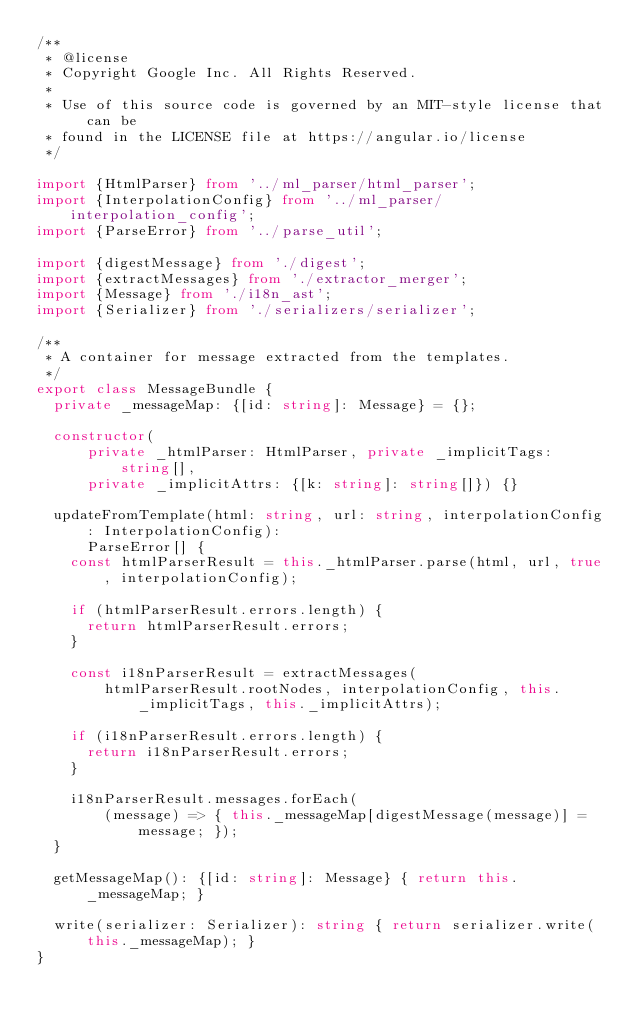Convert code to text. <code><loc_0><loc_0><loc_500><loc_500><_TypeScript_>/**
 * @license
 * Copyright Google Inc. All Rights Reserved.
 *
 * Use of this source code is governed by an MIT-style license that can be
 * found in the LICENSE file at https://angular.io/license
 */

import {HtmlParser} from '../ml_parser/html_parser';
import {InterpolationConfig} from '../ml_parser/interpolation_config';
import {ParseError} from '../parse_util';

import {digestMessage} from './digest';
import {extractMessages} from './extractor_merger';
import {Message} from './i18n_ast';
import {Serializer} from './serializers/serializer';

/**
 * A container for message extracted from the templates.
 */
export class MessageBundle {
  private _messageMap: {[id: string]: Message} = {};

  constructor(
      private _htmlParser: HtmlParser, private _implicitTags: string[],
      private _implicitAttrs: {[k: string]: string[]}) {}

  updateFromTemplate(html: string, url: string, interpolationConfig: InterpolationConfig):
      ParseError[] {
    const htmlParserResult = this._htmlParser.parse(html, url, true, interpolationConfig);

    if (htmlParserResult.errors.length) {
      return htmlParserResult.errors;
    }

    const i18nParserResult = extractMessages(
        htmlParserResult.rootNodes, interpolationConfig, this._implicitTags, this._implicitAttrs);

    if (i18nParserResult.errors.length) {
      return i18nParserResult.errors;
    }

    i18nParserResult.messages.forEach(
        (message) => { this._messageMap[digestMessage(message)] = message; });
  }

  getMessageMap(): {[id: string]: Message} { return this._messageMap; }

  write(serializer: Serializer): string { return serializer.write(this._messageMap); }
}
</code> 